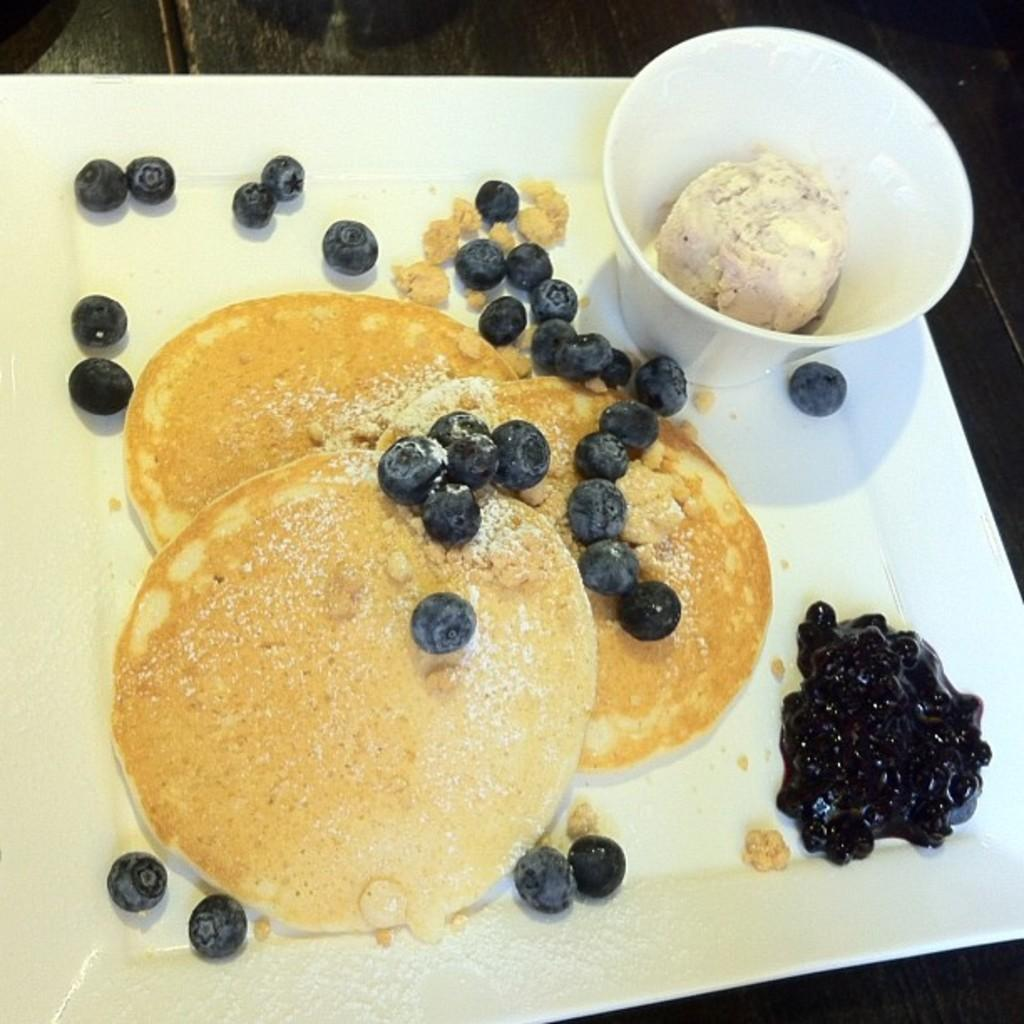What types of food items can be seen in the image? There are food items in the image. What is the container for the food in the cup? There is a cup in the image. What is the cup placed on? The cup is on a white plate. What is inside the cup? There is food in the cup. What type of skirt is being worn by the food in the image? There is no skirt present in the image, as the subject is food and not a person wearing clothing. 